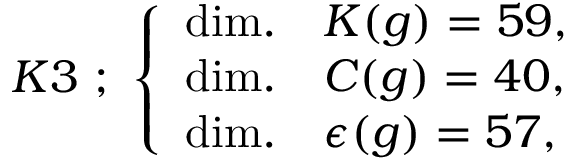Convert formula to latex. <formula><loc_0><loc_0><loc_500><loc_500>K 3 ; \left \{ \begin{array} { l l } { d i m . } & { K ( g ) = 5 9 , } \\ { d i m . } & { C ( g ) = 4 0 , } \\ { d i m . } & { \epsilon ( g ) = 5 7 , } \end{array}</formula> 